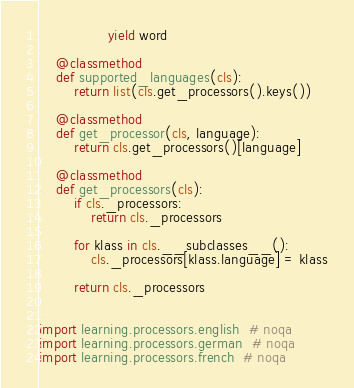<code> <loc_0><loc_0><loc_500><loc_500><_Python_>                yield word

    @classmethod
    def supported_languages(cls):
        return list(cls.get_processors().keys())

    @classmethod
    def get_processor(cls, language):
        return cls.get_processors()[language]

    @classmethod
    def get_processors(cls):
        if cls._processors:
            return cls._processors

        for klass in cls.__subclasses__():
            cls._processors[klass.language] = klass

        return cls._processors


import learning.processors.english  # noqa
import learning.processors.german  # noqa
import learning.processors.french  # noqa
</code> 